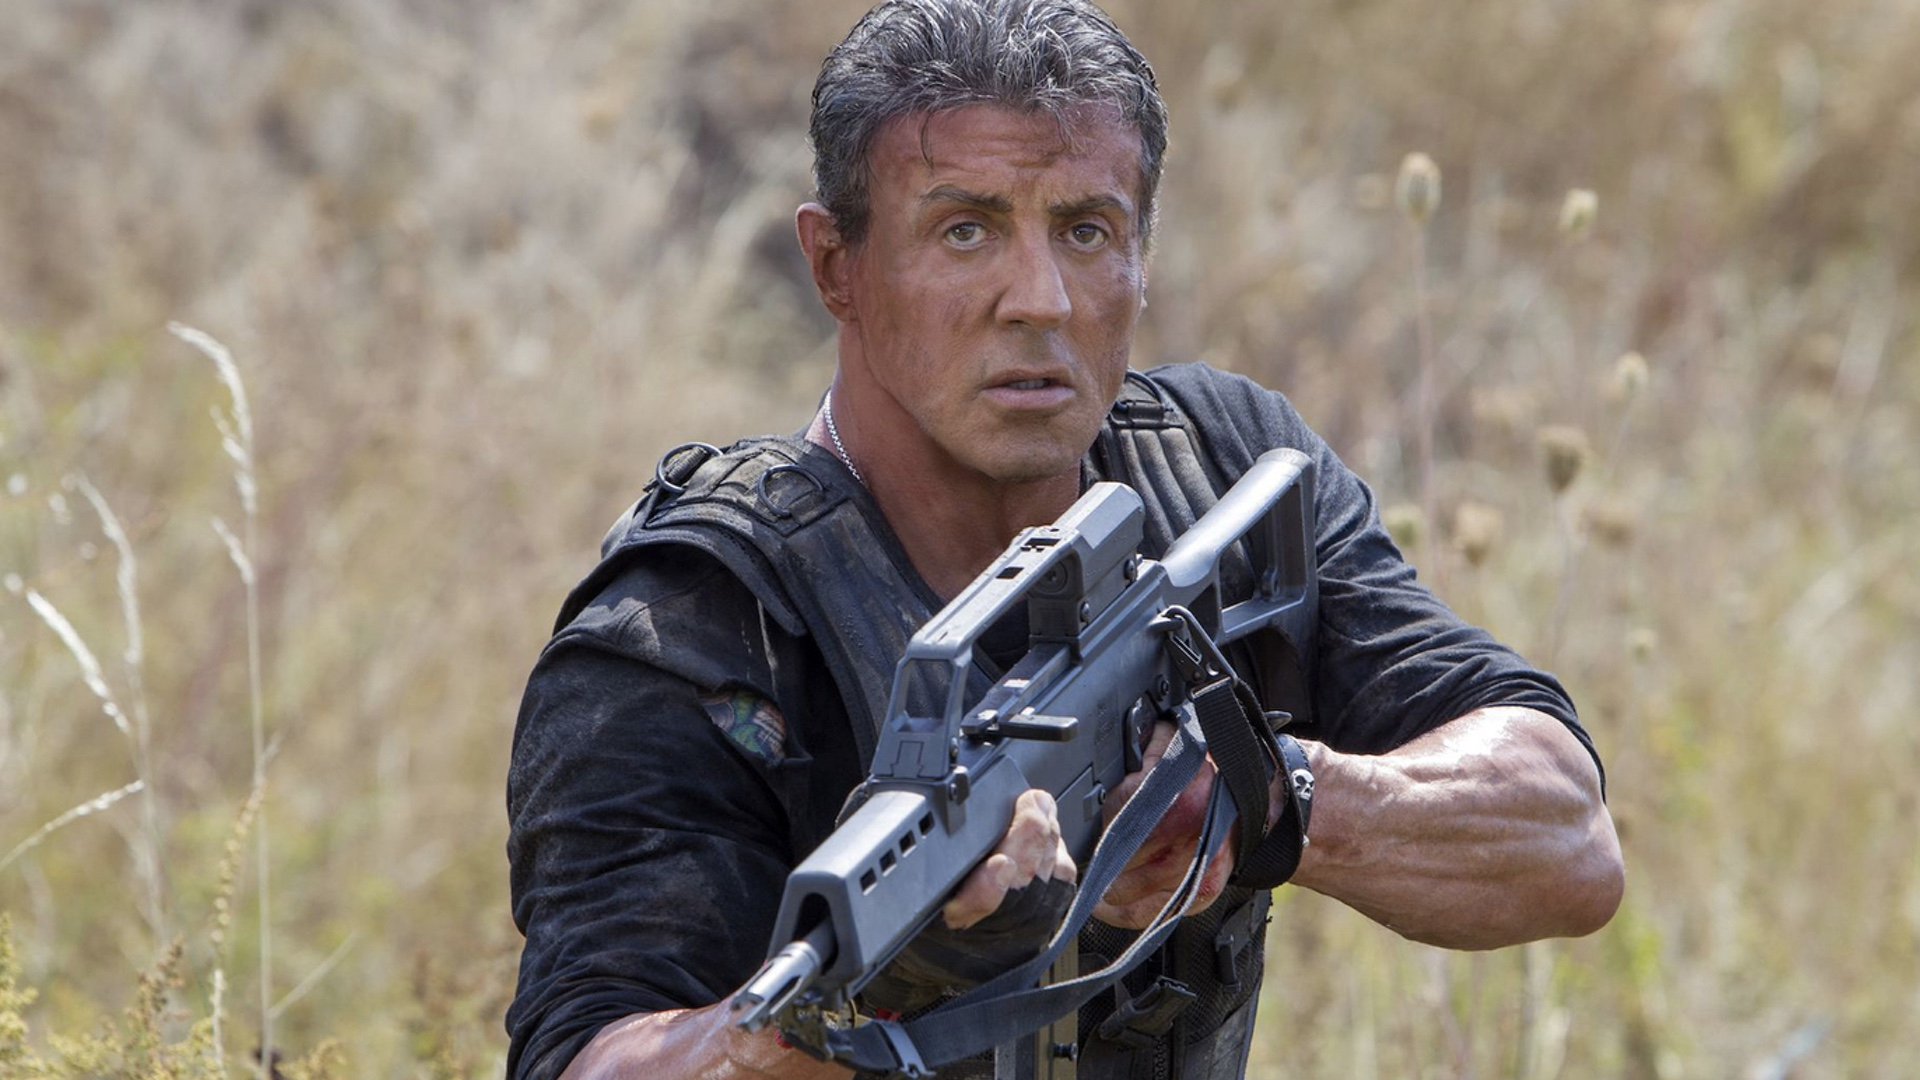Can you elaborate on the elements of the picture provided? This image depicts a rugged male character in an action pose, set against a natural backdrop with tall grass and wildflowers. He is prepared for combat, gripping a large, futuristic-looking firearm with a determined expression. His attire includes a dark, sleeveless tactical vest and worn gear, suggesting readiness and resilience. The overcast sky contributes to the tense atmosphere, enhancing the sense of an imminent conflict. The contrast between his dark clothing and the lighter, natural environment emphasizes the character's solitary and formidable presence. 